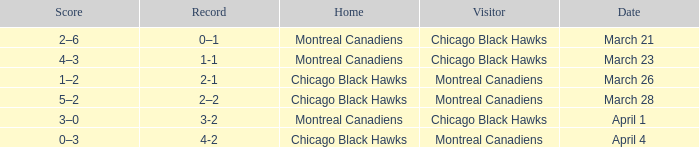Which home team has a record of 3-2? Montreal Canadiens. 